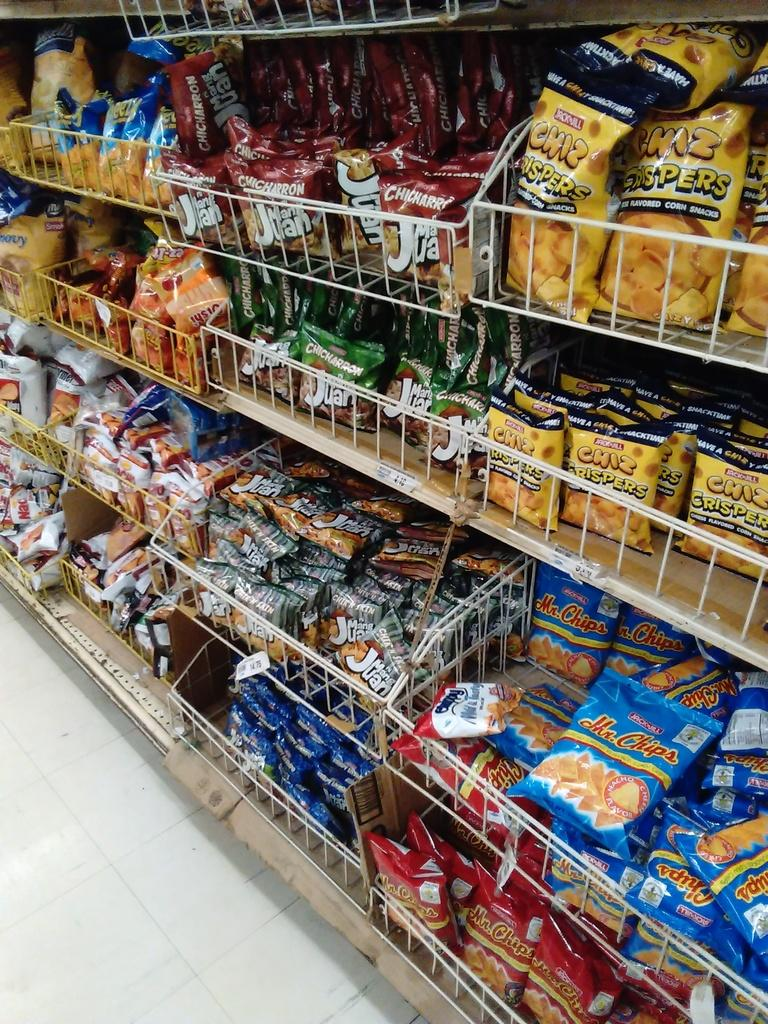<image>
Relay a brief, clear account of the picture shown. The snack aisle of a store is fully stocked with Chiz Crispers, Chicharron's, and several other salty snacks. 